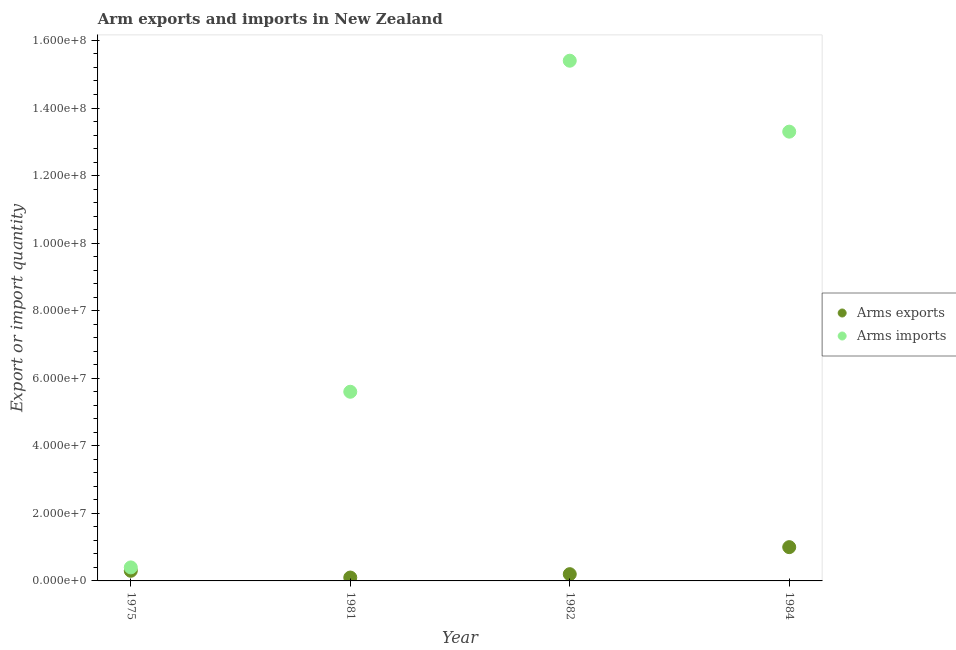How many different coloured dotlines are there?
Your response must be concise. 2. What is the arms imports in 1975?
Provide a succinct answer. 4.00e+06. Across all years, what is the maximum arms exports?
Make the answer very short. 1.00e+07. Across all years, what is the minimum arms exports?
Your response must be concise. 1.00e+06. In which year was the arms imports maximum?
Provide a short and direct response. 1982. In which year was the arms imports minimum?
Provide a short and direct response. 1975. What is the total arms exports in the graph?
Your answer should be compact. 1.60e+07. What is the difference between the arms imports in 1975 and that in 1981?
Offer a very short reply. -5.20e+07. What is the difference between the arms imports in 1982 and the arms exports in 1981?
Keep it short and to the point. 1.53e+08. In the year 1981, what is the difference between the arms imports and arms exports?
Make the answer very short. 5.50e+07. In how many years, is the arms imports greater than 68000000?
Your answer should be very brief. 2. What is the ratio of the arms exports in 1981 to that in 1982?
Provide a succinct answer. 0.5. What is the difference between the highest and the second highest arms imports?
Your answer should be compact. 2.10e+07. What is the difference between the highest and the lowest arms imports?
Your response must be concise. 1.50e+08. In how many years, is the arms imports greater than the average arms imports taken over all years?
Ensure brevity in your answer.  2. How many dotlines are there?
Ensure brevity in your answer.  2. What is the difference between two consecutive major ticks on the Y-axis?
Provide a short and direct response. 2.00e+07. Where does the legend appear in the graph?
Your answer should be compact. Center right. What is the title of the graph?
Offer a terse response. Arm exports and imports in New Zealand. Does "Manufacturing industries and construction" appear as one of the legend labels in the graph?
Give a very brief answer. No. What is the label or title of the Y-axis?
Make the answer very short. Export or import quantity. What is the Export or import quantity of Arms imports in 1981?
Ensure brevity in your answer.  5.60e+07. What is the Export or import quantity of Arms imports in 1982?
Provide a succinct answer. 1.54e+08. What is the Export or import quantity of Arms imports in 1984?
Provide a succinct answer. 1.33e+08. Across all years, what is the maximum Export or import quantity in Arms exports?
Provide a short and direct response. 1.00e+07. Across all years, what is the maximum Export or import quantity of Arms imports?
Your answer should be very brief. 1.54e+08. What is the total Export or import quantity of Arms exports in the graph?
Make the answer very short. 1.60e+07. What is the total Export or import quantity of Arms imports in the graph?
Offer a terse response. 3.47e+08. What is the difference between the Export or import quantity in Arms imports in 1975 and that in 1981?
Offer a very short reply. -5.20e+07. What is the difference between the Export or import quantity of Arms exports in 1975 and that in 1982?
Offer a terse response. 1.00e+06. What is the difference between the Export or import quantity of Arms imports in 1975 and that in 1982?
Ensure brevity in your answer.  -1.50e+08. What is the difference between the Export or import quantity in Arms exports in 1975 and that in 1984?
Provide a succinct answer. -7.00e+06. What is the difference between the Export or import quantity of Arms imports in 1975 and that in 1984?
Make the answer very short. -1.29e+08. What is the difference between the Export or import quantity in Arms exports in 1981 and that in 1982?
Keep it short and to the point. -1.00e+06. What is the difference between the Export or import quantity in Arms imports in 1981 and that in 1982?
Your response must be concise. -9.80e+07. What is the difference between the Export or import quantity in Arms exports in 1981 and that in 1984?
Provide a succinct answer. -9.00e+06. What is the difference between the Export or import quantity in Arms imports in 1981 and that in 1984?
Keep it short and to the point. -7.70e+07. What is the difference between the Export or import quantity of Arms exports in 1982 and that in 1984?
Give a very brief answer. -8.00e+06. What is the difference between the Export or import quantity in Arms imports in 1982 and that in 1984?
Give a very brief answer. 2.10e+07. What is the difference between the Export or import quantity of Arms exports in 1975 and the Export or import quantity of Arms imports in 1981?
Keep it short and to the point. -5.30e+07. What is the difference between the Export or import quantity in Arms exports in 1975 and the Export or import quantity in Arms imports in 1982?
Provide a short and direct response. -1.51e+08. What is the difference between the Export or import quantity in Arms exports in 1975 and the Export or import quantity in Arms imports in 1984?
Offer a terse response. -1.30e+08. What is the difference between the Export or import quantity in Arms exports in 1981 and the Export or import quantity in Arms imports in 1982?
Make the answer very short. -1.53e+08. What is the difference between the Export or import quantity of Arms exports in 1981 and the Export or import quantity of Arms imports in 1984?
Offer a very short reply. -1.32e+08. What is the difference between the Export or import quantity in Arms exports in 1982 and the Export or import quantity in Arms imports in 1984?
Offer a terse response. -1.31e+08. What is the average Export or import quantity in Arms exports per year?
Give a very brief answer. 4.00e+06. What is the average Export or import quantity in Arms imports per year?
Your response must be concise. 8.68e+07. In the year 1981, what is the difference between the Export or import quantity of Arms exports and Export or import quantity of Arms imports?
Your answer should be very brief. -5.50e+07. In the year 1982, what is the difference between the Export or import quantity of Arms exports and Export or import quantity of Arms imports?
Your answer should be compact. -1.52e+08. In the year 1984, what is the difference between the Export or import quantity of Arms exports and Export or import quantity of Arms imports?
Offer a very short reply. -1.23e+08. What is the ratio of the Export or import quantity of Arms exports in 1975 to that in 1981?
Your answer should be compact. 3. What is the ratio of the Export or import quantity in Arms imports in 1975 to that in 1981?
Your answer should be compact. 0.07. What is the ratio of the Export or import quantity in Arms exports in 1975 to that in 1982?
Keep it short and to the point. 1.5. What is the ratio of the Export or import quantity in Arms imports in 1975 to that in 1982?
Provide a succinct answer. 0.03. What is the ratio of the Export or import quantity in Arms exports in 1975 to that in 1984?
Provide a short and direct response. 0.3. What is the ratio of the Export or import quantity in Arms imports in 1975 to that in 1984?
Keep it short and to the point. 0.03. What is the ratio of the Export or import quantity of Arms exports in 1981 to that in 1982?
Offer a very short reply. 0.5. What is the ratio of the Export or import quantity of Arms imports in 1981 to that in 1982?
Your answer should be very brief. 0.36. What is the ratio of the Export or import quantity in Arms exports in 1981 to that in 1984?
Your response must be concise. 0.1. What is the ratio of the Export or import quantity of Arms imports in 1981 to that in 1984?
Your answer should be compact. 0.42. What is the ratio of the Export or import quantity of Arms imports in 1982 to that in 1984?
Provide a short and direct response. 1.16. What is the difference between the highest and the second highest Export or import quantity in Arms imports?
Offer a terse response. 2.10e+07. What is the difference between the highest and the lowest Export or import quantity of Arms exports?
Your answer should be very brief. 9.00e+06. What is the difference between the highest and the lowest Export or import quantity of Arms imports?
Ensure brevity in your answer.  1.50e+08. 